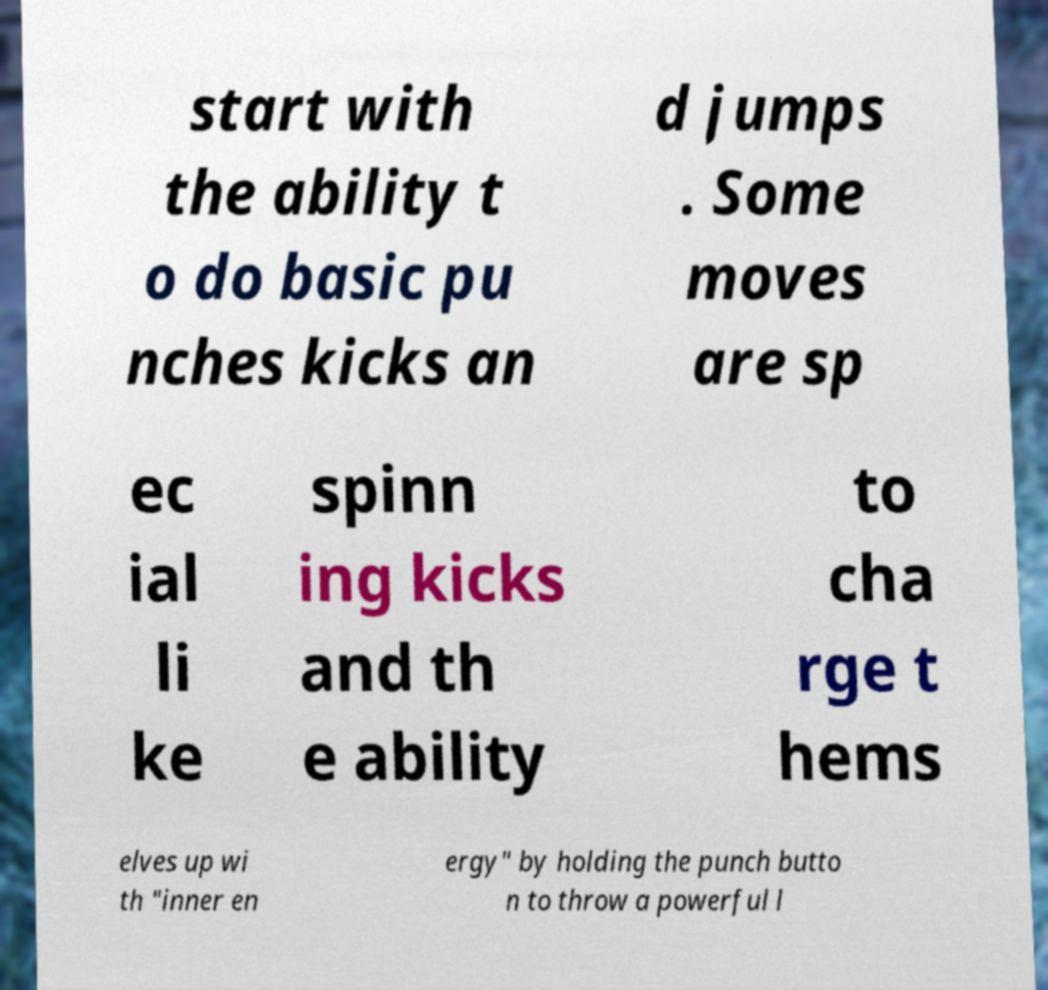Can you accurately transcribe the text from the provided image for me? start with the ability t o do basic pu nches kicks an d jumps . Some moves are sp ec ial li ke spinn ing kicks and th e ability to cha rge t hems elves up wi th "inner en ergy" by holding the punch butto n to throw a powerful l 